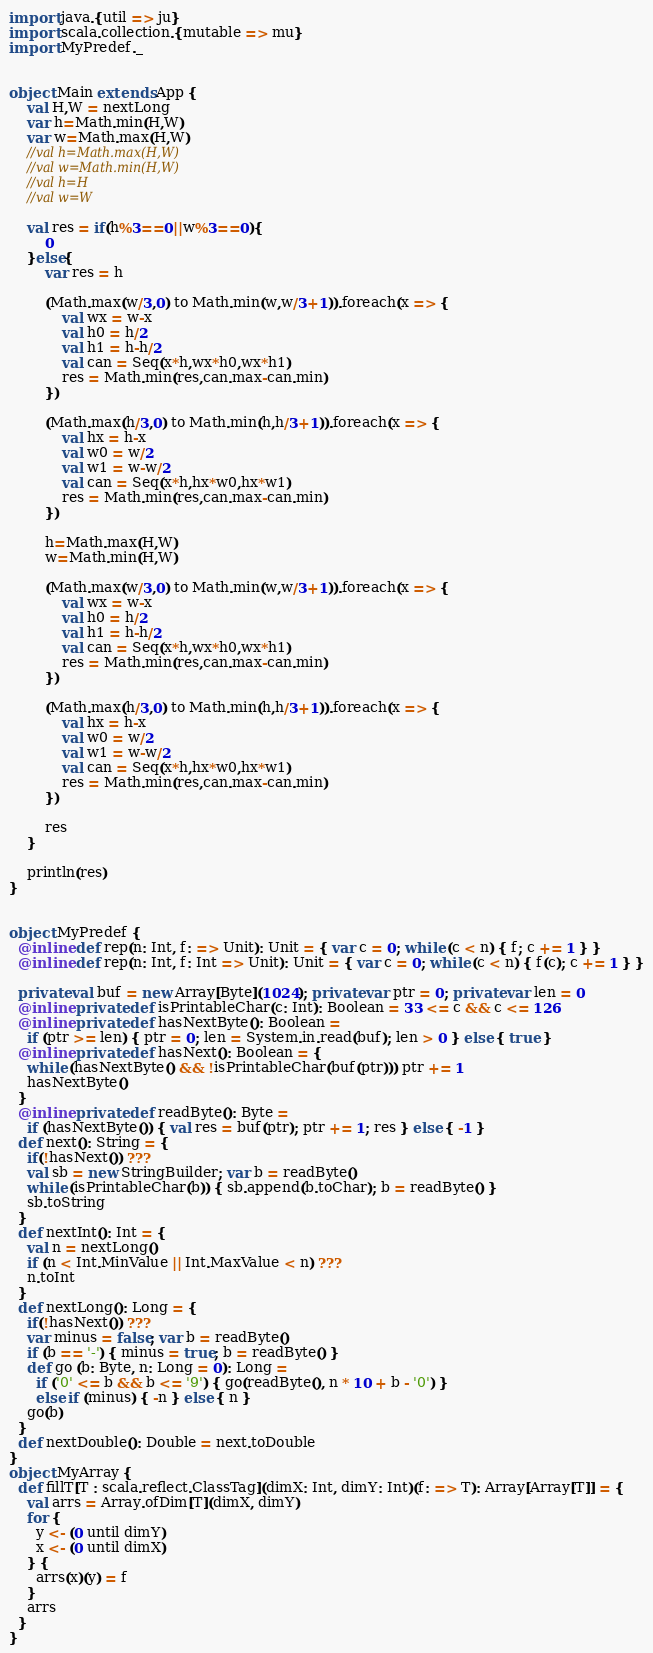<code> <loc_0><loc_0><loc_500><loc_500><_Scala_>import java.{util => ju}
import scala.collection.{mutable => mu}
import MyPredef._


object Main extends App {
    val H,W = nextLong
    var h=Math.min(H,W)
    var w=Math.max(H,W)
    //val h=Math.max(H,W)
    //val w=Math.min(H,W)
    //val h=H
    //val w=W
    
    val res = if(h%3==0||w%3==0){
        0
    }else{
        var res = h
        
        (Math.max(w/3,0) to Math.min(w,w/3+1)).foreach(x => {
            val wx = w-x
            val h0 = h/2
            val h1 = h-h/2
            val can = Seq(x*h,wx*h0,wx*h1)
            res = Math.min(res,can.max-can.min)
        })
         
        (Math.max(h/3,0) to Math.min(h,h/3+1)).foreach(x => {
            val hx = h-x
            val w0 = w/2
            val w1 = w-w/2
            val can = Seq(x*h,hx*w0,hx*w1)
            res = Math.min(res,can.max-can.min)
        })
        
        h=Math.max(H,W)
        w=Math.min(H,W)
        
        (Math.max(w/3,0) to Math.min(w,w/3+1)).foreach(x => {
            val wx = w-x
            val h0 = h/2
            val h1 = h-h/2
            val can = Seq(x*h,wx*h0,wx*h1)
            res = Math.min(res,can.max-can.min)
        })
         
        (Math.max(h/3,0) to Math.min(h,h/3+1)).foreach(x => {
            val hx = h-x
            val w0 = w/2
            val w1 = w-w/2
            val can = Seq(x*h,hx*w0,hx*w1)
            res = Math.min(res,can.max-can.min)
        })
        
        res
    }
    
    println(res)
}


object MyPredef {
  @inline def rep(n: Int, f: => Unit): Unit = { var c = 0; while (c < n) { f; c += 1 } }
  @inline def rep(n: Int, f: Int => Unit): Unit = { var c = 0; while (c < n) { f(c); c += 1 } }

  private val buf = new Array[Byte](1024); private var ptr = 0; private var len = 0
  @inline private def isPrintableChar(c: Int): Boolean = 33 <= c && c <= 126
  @inline private def hasNextByte(): Boolean =
    if (ptr >= len) { ptr = 0; len = System.in.read(buf); len > 0 } else { true }
  @inline private def hasNext(): Boolean = {
    while (hasNextByte() && !isPrintableChar(buf(ptr))) ptr += 1
    hasNextByte()
  }
  @inline private def readByte(): Byte =
    if (hasNextByte()) { val res = buf(ptr); ptr += 1; res } else { -1 }
  def next(): String = {
    if(!hasNext()) ???
    val sb = new StringBuilder; var b = readByte()
    while (isPrintableChar(b)) { sb.append(b.toChar); b = readByte() }
    sb.toString
  }
  def nextInt(): Int = {
    val n = nextLong()
    if (n < Int.MinValue || Int.MaxValue < n) ???
    n.toInt
  }
  def nextLong(): Long = {
    if(!hasNext()) ???
    var minus = false; var b = readByte()
    if (b == '-') { minus = true; b = readByte() }
    def go (b: Byte, n: Long = 0): Long =
      if ('0' <= b && b <= '9') { go(readByte(), n * 10 + b - '0') }
      else if (minus) { -n } else { n }
    go(b)
  }
  def nextDouble(): Double = next.toDouble
}
object MyArray {
  def fillT[T : scala.reflect.ClassTag](dimX: Int, dimY: Int)(f: => T): Array[Array[T]] = {
    val arrs = Array.ofDim[T](dimX, dimY)
    for {
      y <- (0 until dimY)
      x <- (0 until dimX)
    } {
      arrs(x)(y) = f
    }
    arrs
  }
}</code> 